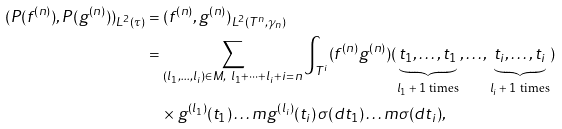Convert formula to latex. <formula><loc_0><loc_0><loc_500><loc_500>( P ( f ^ { ( n ) } ) , P ( g ^ { ( n ) } ) ) _ { L ^ { 2 } ( \tau ) } & = ( f ^ { ( n ) } , g ^ { ( n ) } ) _ { L ^ { 2 } ( T ^ { n } , \gamma _ { n } ) } \\ & = \sum _ { ( l _ { 1 } , \dots , l _ { i } ) \in M , \ l _ { 1 } + \dots + l _ { i } + i = n } \int _ { T ^ { i } } ( f ^ { ( n ) } g ^ { ( n ) } ) ( \underbrace { t _ { 1 } , \dots , t _ { 1 } } _ { \text {$l_{1}+1$ times} } , \dots , \underbrace { t _ { i } , \dots , t _ { i } } _ { \text {$l_{i}+1$ times} } ) \\ & \quad \times g ^ { ( l _ { 1 } ) } ( t _ { 1 } ) \dots m g ^ { ( l _ { i } ) } ( t _ { i } ) \, \sigma ( d t _ { 1 } ) \dots m \sigma ( d t _ { i } ) ,</formula> 